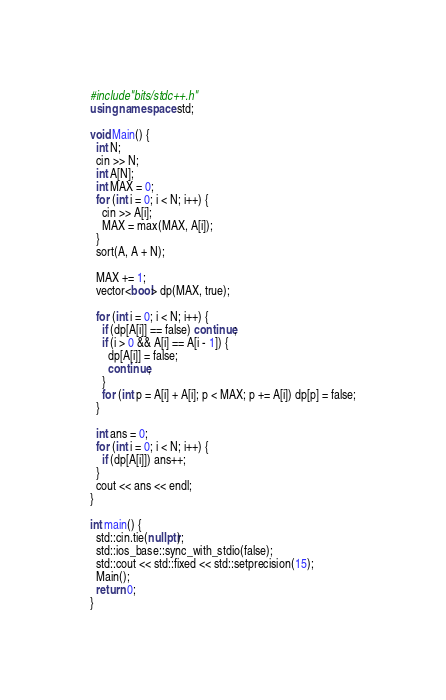<code> <loc_0><loc_0><loc_500><loc_500><_C++_>#include"bits/stdc++.h"
using namespace std;

void Main() {
  int N;
  cin >> N;
  int A[N];
  int MAX = 0;
  for (int i = 0; i < N; i++) {
    cin >> A[i];
    MAX = max(MAX, A[i]);
  }
  sort(A, A + N);

  MAX += 1;
  vector<bool> dp(MAX, true);

  for (int i = 0; i < N; i++) {
    if (dp[A[i]] == false) continue;
    if (i > 0 && A[i] == A[i - 1]) {
      dp[A[i]] = false;
      continue;
    }
    for (int p = A[i] + A[i]; p < MAX; p += A[i]) dp[p] = false;
  }

  int ans = 0;
  for (int i = 0; i < N; i++) {
    if (dp[A[i]]) ans++;
  }
  cout << ans << endl;
}

int main() {
  std::cin.tie(nullptr);
  std::ios_base::sync_with_stdio(false);
  std::cout << std::fixed << std::setprecision(15);
  Main();
  return 0;
}

</code> 